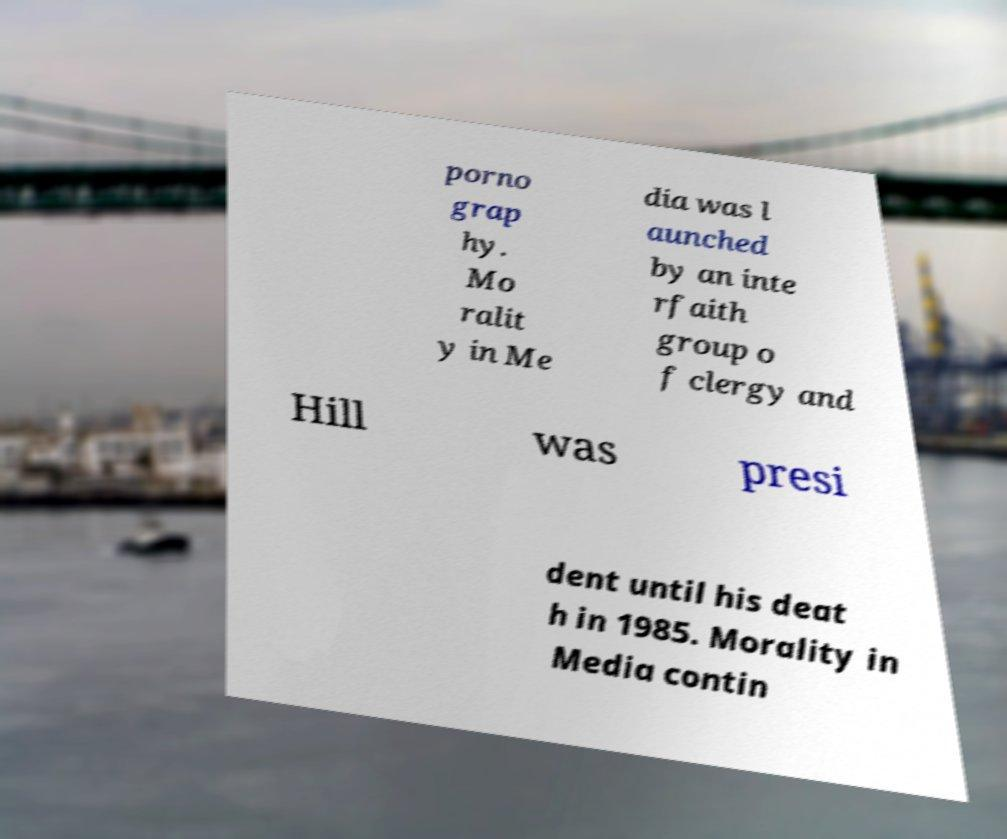For documentation purposes, I need the text within this image transcribed. Could you provide that? porno grap hy. Mo ralit y in Me dia was l aunched by an inte rfaith group o f clergy and Hill was presi dent until his deat h in 1985. Morality in Media contin 